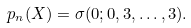<formula> <loc_0><loc_0><loc_500><loc_500>p _ { n } ( X ) = \sigma ( 0 ; 0 , 3 , \dots , 3 ) .</formula> 